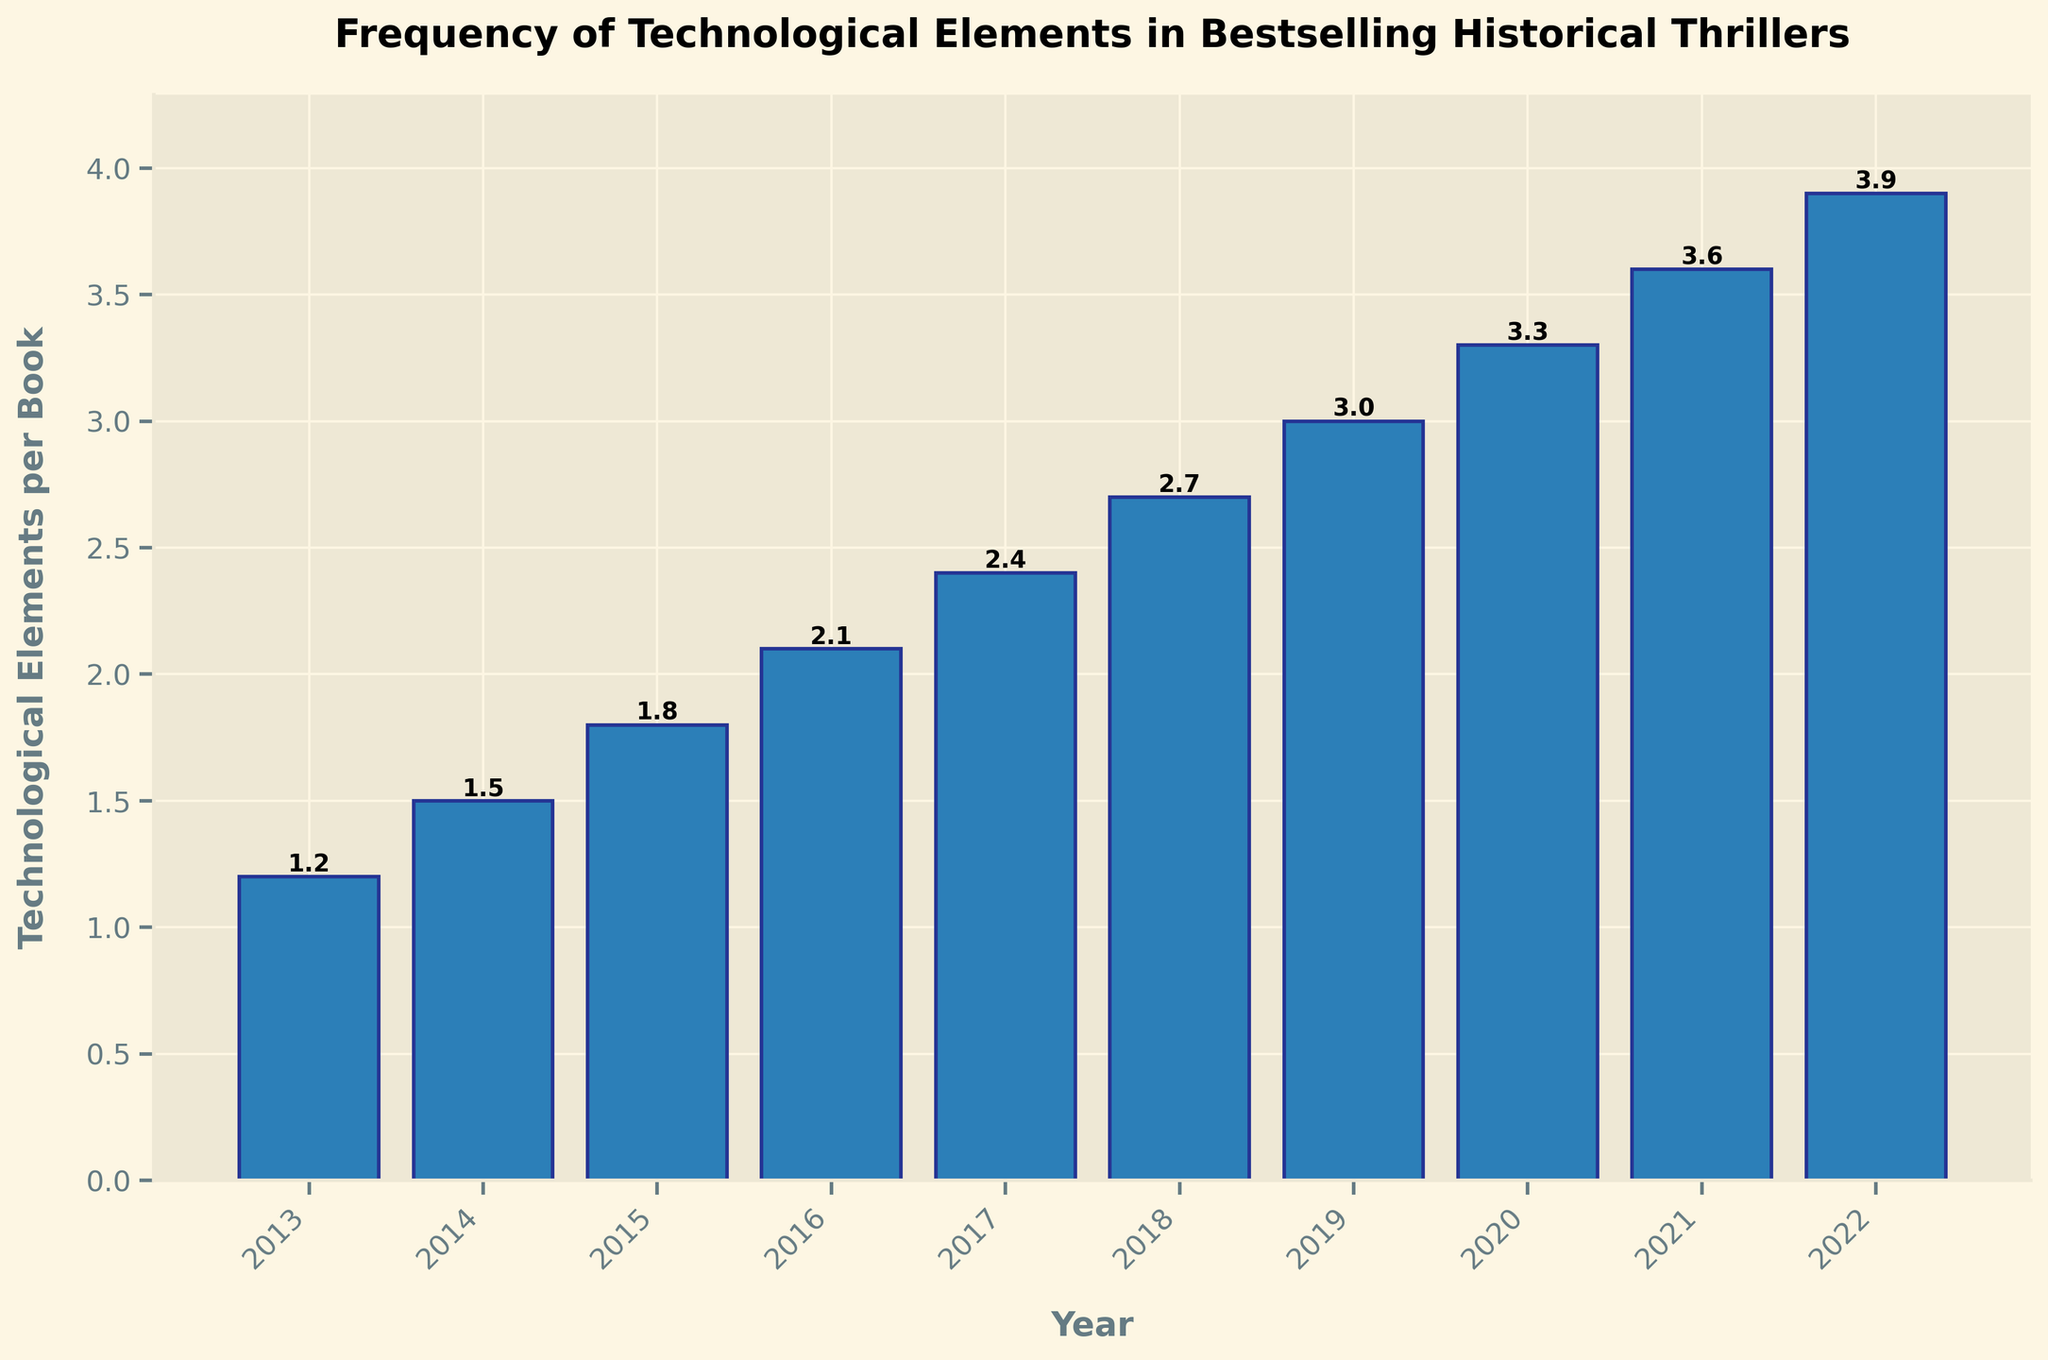Which year had the highest number of technological elements per book? The year 2022 has the bar with the greatest height, indicating the highest number of technological elements per book.
Answer: 2022 How many more technological elements per book were there in 2022 compared to 2013? The bar for 2022 shows 3.9 elements, and the bar for 2013 shows 1.2 elements. Subtracting these values, 3.9 - 1.2 = 2.7 more elements.
Answer: 2.7 What is the average number of technological elements per book over the decade? Adding the values (1.2, 1.5, 1.8, 2.1, 2.4, 2.7, 3.0, 3.3, 3.6, 3.9) and dividing by 10, the average is (1.2 + 1.5 + 1.8 + 2.1 + 2.4 + 2.7 + 3.0 + 3.3 + 3.6 + 3.9) / 10 = 26.5 / 10 = 2.65.
Answer: 2.65 Which years saw a consistent increase in technological elements per book over the previous year? Observing the bar heights, the technological elements increased every year from 2013 to 2022. A consistent increase is seen each year.
Answer: From 2013 to 2022 What was the total increase in technological elements per book from 2013 to 2022? The number of elements in 2013 is 1.2, and in 2022 it is 3.9. The total increase is 3.9 - 1.2 = 2.7.
Answer: 2.7 Was there any year when the technological elements per book decreased? The heights of the bars increase each year, indicating that there was no decrease in any year.
Answer: No How many years had more than 3 technological elements per book? The bars for the years 2019, 2020, 2021, and 2022 all show values above 3.
Answer: 4 Between which two consecutive years did the largest increase in the number of technological elements per book occur? The bar for 2017 shows 2.4 elements, and the bar for 2018 shows 2.7 elements. The largest increase is between 2017 and 2018, which is 2.7 - 2.4 = 0.3. Another significant increase is between 2021 (3.6) and 2022 (3.9), also 0.3.
Answer: 2017-2018 and 2021-2022 What is the median number of technological elements per book over the years? Ordering the values (1.2, 1.5, 1.8, 2.1, 2.4, 2.7, 3.0, 3.3, 3.6, 3.9) and finding the middle value(s), the median is the average of the 5th and 6th values (2.4 and 2.7), so (2.4 + 2.7)/2 = 2.55.
Answer: 2.55 